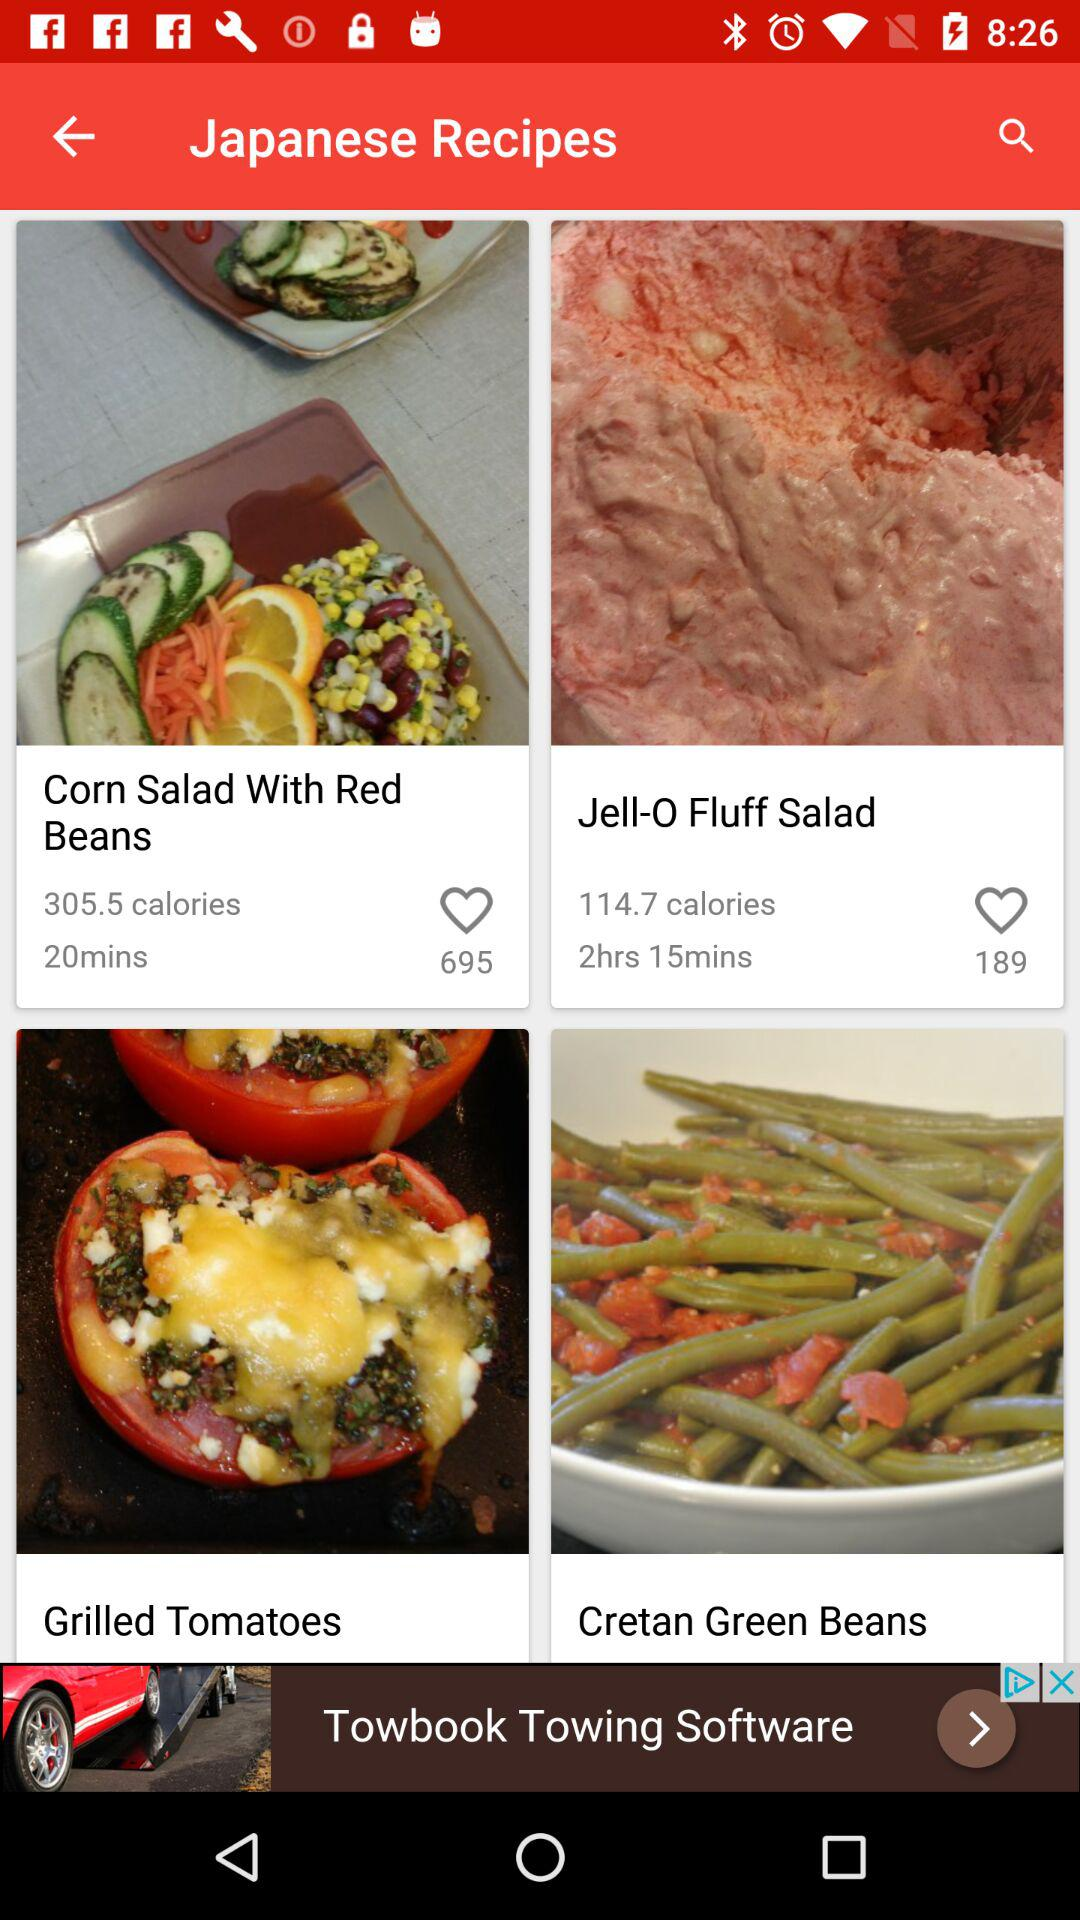How many calories are contained in the recipe "Jell-O Fluff Salad"? There are 114.7 calories are contained in the recipe "Jell-O Fluff Salad". 